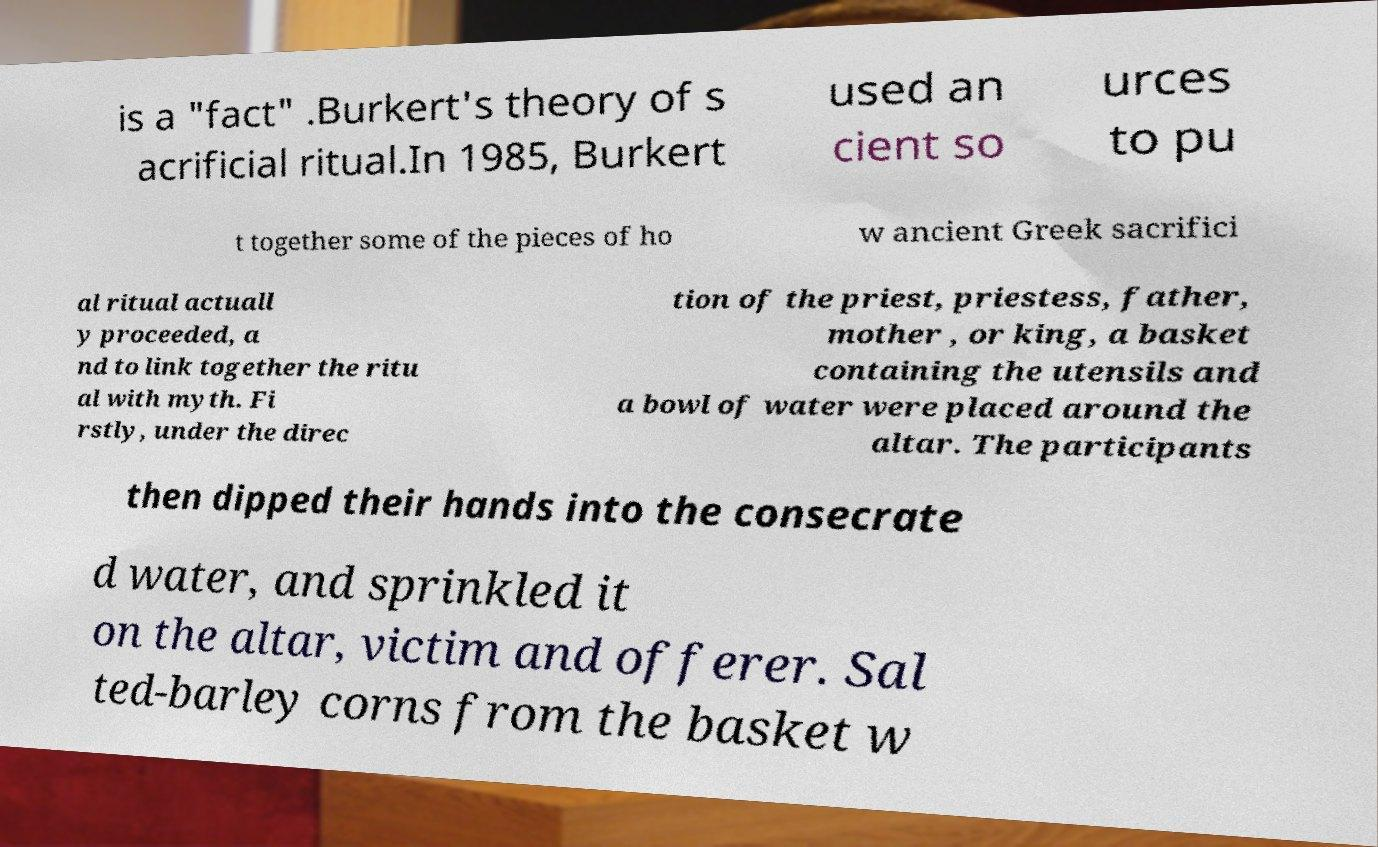I need the written content from this picture converted into text. Can you do that? is a "fact" .Burkert's theory of s acrificial ritual.In 1985, Burkert used an cient so urces to pu t together some of the pieces of ho w ancient Greek sacrifici al ritual actuall y proceeded, a nd to link together the ritu al with myth. Fi rstly, under the direc tion of the priest, priestess, father, mother , or king, a basket containing the utensils and a bowl of water were placed around the altar. The participants then dipped their hands into the consecrate d water, and sprinkled it on the altar, victim and offerer. Sal ted-barley corns from the basket w 